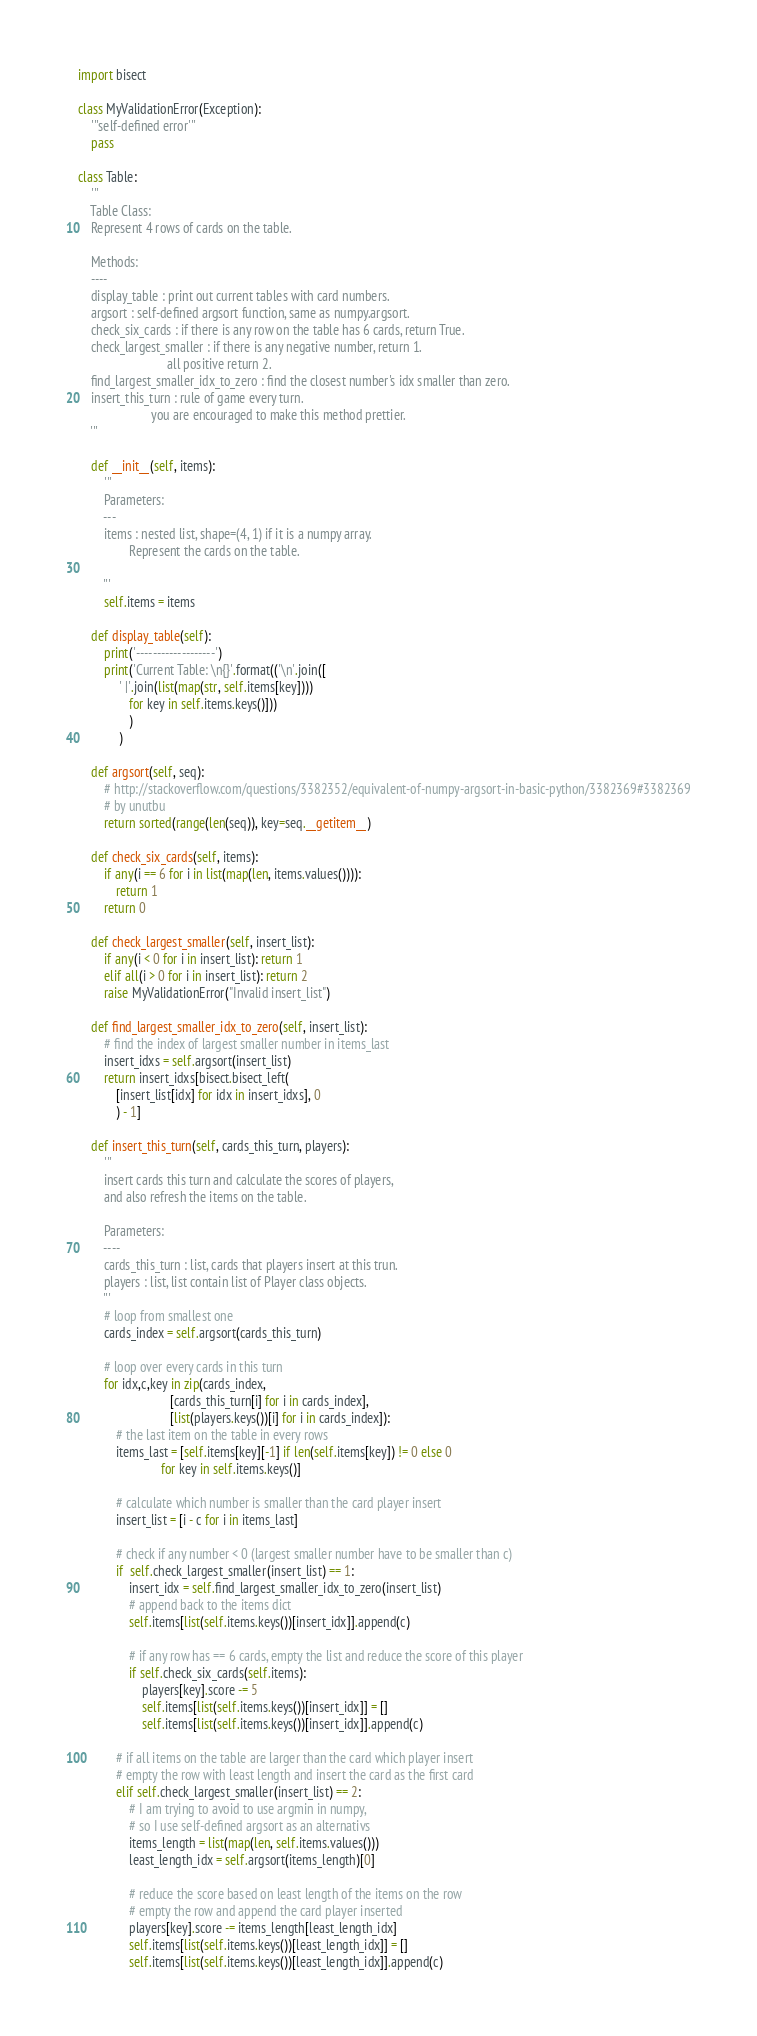Convert code to text. <code><loc_0><loc_0><loc_500><loc_500><_Python_>import bisect

class MyValidationError(Exception):
    '''self-defined error'''
    pass

class Table:
    '''
    Table Class: 
    Represent 4 rows of cards on the table.

    Methods:
    ----
    display_table : print out current tables with card numbers.
    argsort : self-defined argsort function, same as numpy.argsort.
    check_six_cards : if there is any row on the table has 6 cards, return True.
    check_largest_smaller : if there is any negative number, return 1. 
                            all positive return 2.
    find_largest_smaller_idx_to_zero : find the closest number's idx smaller than zero.
    insert_this_turn : rule of game every turn. 
                       you are encouraged to make this method prettier. 
    '''
    
    def __init__(self, items):
        '''
        Parameters:
        ---
        items : nested list, shape=(4, 1) if it is a numpy array.
                Represent the cards on the table.
        
        '''
        self.items = items
        
    def display_table(self):
        print('-------------------')
        print('Current Table: \n{}'.format(('\n'.join([ 
             ' |'.join(list(map(str, self.items[key]))) 
                for key in self.items.keys()]))
                )
             )
    
    def argsort(self, seq):
        # http://stackoverflow.com/questions/3382352/equivalent-of-numpy-argsort-in-basic-python/3382369#3382369
        # by unutbu
        return sorted(range(len(seq)), key=seq.__getitem__)
    
    def check_six_cards(self, items):
        if any(i == 6 for i in list(map(len, items.values()))):
            return 1
        return 0

    def check_largest_smaller(self, insert_list):
        if any(i < 0 for i in insert_list): return 1
        elif all(i > 0 for i in insert_list): return 2
        raise MyValidationError("Invalid insert_list")

    def find_largest_smaller_idx_to_zero(self, insert_list):
        # find the index of largest smaller number in items_last
        insert_idxs = self.argsort(insert_list)
        return insert_idxs[bisect.bisect_left(
            [insert_list[idx] for idx in insert_idxs], 0
            ) - 1]
    
    def insert_this_turn(self, cards_this_turn, players):
        '''
        insert cards this turn and calculate the scores of players, 
        and also refresh the items on the table.
        
        Parameters:
        ----
        cards_this_turn : list, cards that players insert at this trun.
        players : list, list contain list of Player class objects.
        '''
        # loop from smallest one
        cards_index = self.argsort(cards_this_turn)
        
        # loop over every cards in this turn
        for idx,c,key in zip(cards_index, 
                             [cards_this_turn[i] for i in cards_index], 
                             [list(players.keys())[i] for i in cards_index]):
            # the last item on the table in every rows
            items_last = [self.items[key][-1] if len(self.items[key]) != 0 else 0 
                          for key in self.items.keys()]

            # calculate which number is smaller than the card player insert
            insert_list = [i - c for i in items_last]

            # check if any number < 0 (largest smaller number have to be smaller than c)
            if  self.check_largest_smaller(insert_list) == 1:
                insert_idx = self.find_largest_smaller_idx_to_zero(insert_list)
                # append back to the items dict
                self.items[list(self.items.keys())[insert_idx]].append(c)

                # if any row has == 6 cards, empty the list and reduce the score of this player
                if self.check_six_cards(self.items):
                    players[key].score -= 5
                    self.items[list(self.items.keys())[insert_idx]] = []
                    self.items[list(self.items.keys())[insert_idx]].append(c)

            # if all items on the table are larger than the card which player insert
            # empty the row with least length and insert the card as the first card
            elif self.check_largest_smaller(insert_list) == 2:    
                # I am trying to avoid to use argmin in numpy, 
                # so I use self-defined argsort as an alternativs
                items_length = list(map(len, self.items.values()))
                least_length_idx = self.argsort(items_length)[0]

                # reduce the score based on least length of the items on the row
                # empty the row and append the card player inserted
                players[key].score -= items_length[least_length_idx]
                self.items[list(self.items.keys())[least_length_idx]] = []
                self.items[list(self.items.keys())[least_length_idx]].append(c)</code> 